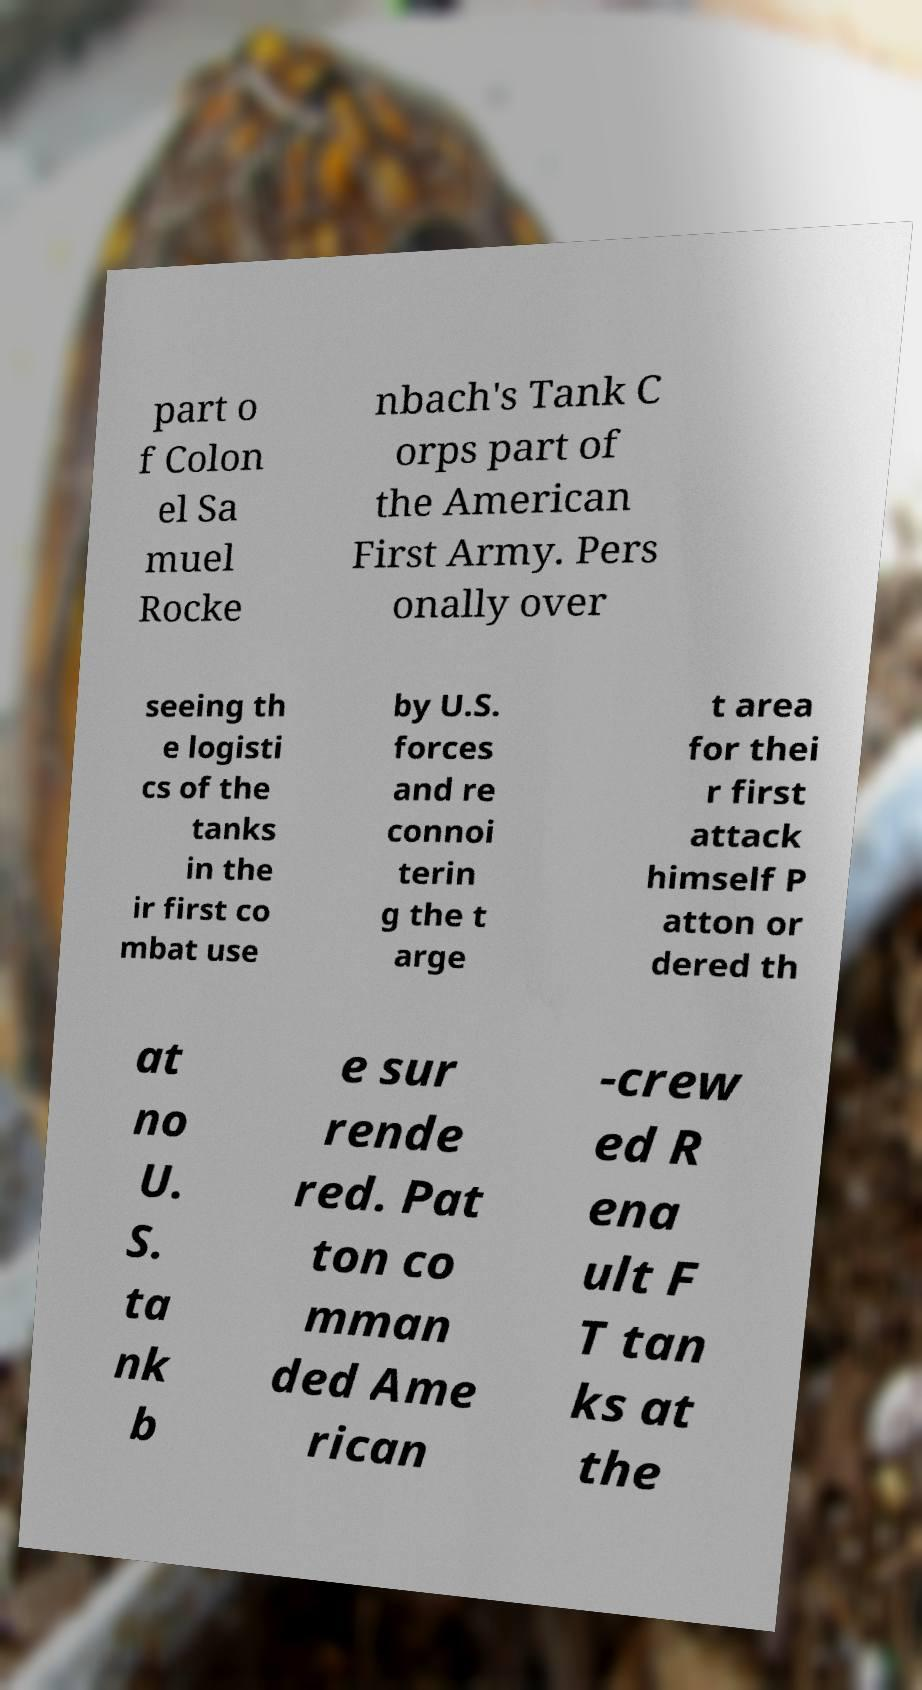There's text embedded in this image that I need extracted. Can you transcribe it verbatim? part o f Colon el Sa muel Rocke nbach's Tank C orps part of the American First Army. Pers onally over seeing th e logisti cs of the tanks in the ir first co mbat use by U.S. forces and re connoi terin g the t arge t area for thei r first attack himself P atton or dered th at no U. S. ta nk b e sur rende red. Pat ton co mman ded Ame rican -crew ed R ena ult F T tan ks at the 